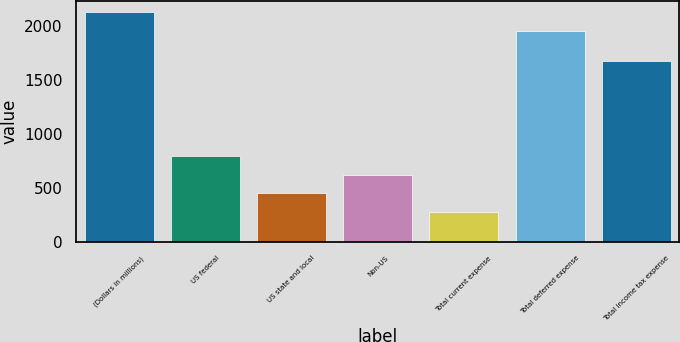<chart> <loc_0><loc_0><loc_500><loc_500><bar_chart><fcel>(Dollars in millions)<fcel>US federal<fcel>US state and local<fcel>Non-US<fcel>Total current expense<fcel>Total deferred expense<fcel>Total income tax expense<nl><fcel>2122.8<fcel>794.4<fcel>446.8<fcel>620.6<fcel>273<fcel>1949<fcel>1676<nl></chart> 